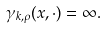Convert formula to latex. <formula><loc_0><loc_0><loc_500><loc_500>\gamma _ { k , \rho } ( x , \cdot ) = \infty .</formula> 